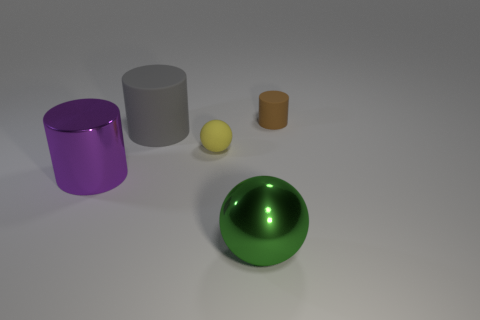What is the tiny brown cylinder made of?
Make the answer very short. Rubber. What is the shape of the object right of the big green shiny thing?
Your answer should be compact. Cylinder. There is a shiny object that is the same size as the green shiny sphere; what is its color?
Your answer should be compact. Purple. Are the thing that is in front of the big purple metallic cylinder and the small brown object made of the same material?
Make the answer very short. No. There is a cylinder that is both behind the purple metal cylinder and in front of the brown thing; what size is it?
Give a very brief answer. Large. There is a cylinder in front of the yellow object; what size is it?
Give a very brief answer. Large. The small rubber thing on the right side of the thing that is in front of the big cylinder in front of the gray cylinder is what shape?
Provide a succinct answer. Cylinder. How many other things are there of the same shape as the big purple metal object?
Provide a short and direct response. 2. What number of rubber things are either green things or brown cylinders?
Your response must be concise. 1. There is a big object in front of the big metal object that is to the left of the small yellow thing; what is its material?
Make the answer very short. Metal. 